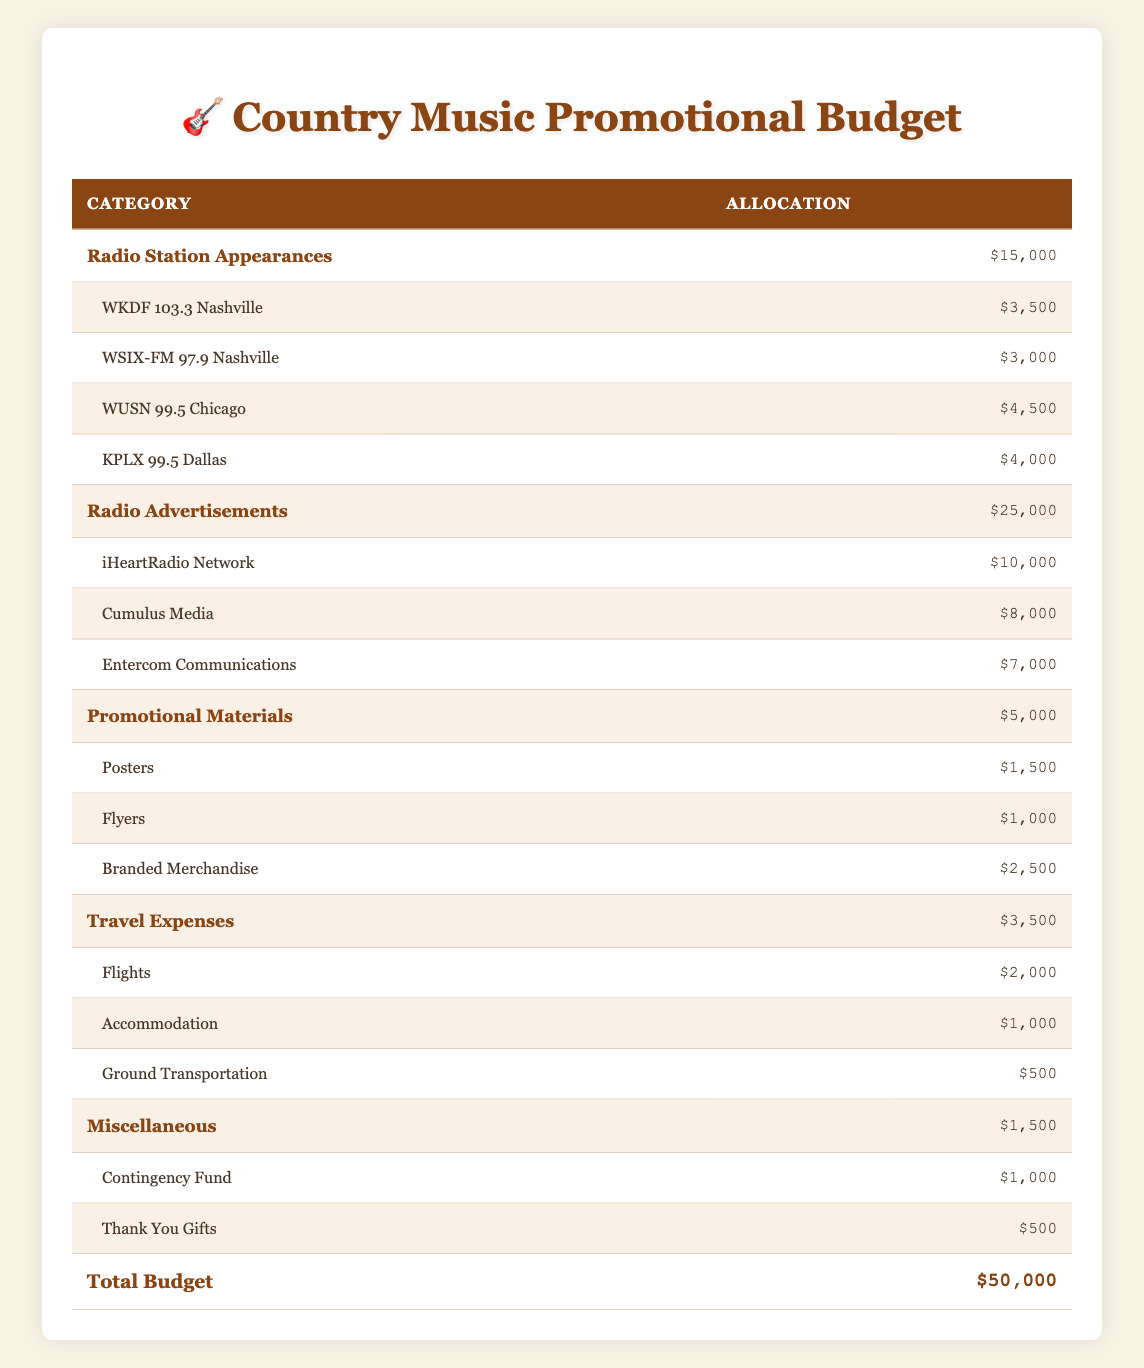What is the total budget allocated for promotional activities? The total budget is explicitly stated in the table under the "Total Budget" row, which shows $50,000.
Answer: $50,000 How much money is allocated for Radio Station Appearances? The amount allocated for Radio Station Appearances is directly listed in the table, indicated as $15,000.
Answer: $15,000 Which radio station has the highest individual allocation? The radio station with the highest allocation can be determined by comparing the amounts for each station: WKDF 103.3 Nashville ($3,500), WSIX-FM 97.9 Nashville ($3,000), WUSN 99.5 Chicago ($4,500), and KPLX 99.5 Dallas ($4,000). WUSN 99.5 Chicago has the highest amount at $4,500.
Answer: WUSN 99.5 Chicago What percentage of the total budget is allocated for Radio Advertisements? To find the percentage, divide the Radio Advertisements allocation of $25,000 by the total budget of $50,000, then multiply by 100: (25,000 / 50,000) * 100 = 50%.
Answer: 50% Is the allocation for Travel Expenses greater than that for Promotional Materials? The allocation for Travel Expenses is $3,500 while for Promotional Materials it is $5,000. Since $3,500 is less than $5,000, the statement is false.
Answer: No If you add the amounts for the three radio advertisement subcategories, what is the total? The total for the radio advertisement subcategories can be calculated by summing iHeartRadio Network ($10,000), Cumulus Media ($8,000), and Entercom Communications ($7,000): 10,000 + 8,000 + 7,000 = $25,000.
Answer: $25,000 What is the combined total allocation for both Radio Station Appearances and Travel Expenses? The combined total is found by adding the allocation for Radio Station Appearances ($15,000) and Travel Expenses ($3,500): 15,000 + 3,500 = $18,500.
Answer: $18,500 Are the funds for Miscellaneous expenses more than the sum of Travel Expenses and Promotional Materials? First, calculate the sum of Travel Expenses ($3,500) and Promotional Materials ($5,000), which equals $8,500. The allocation for Miscellaneous is $1,500, which is less than $8,500. Therefore, the fact is false.
Answer: No 